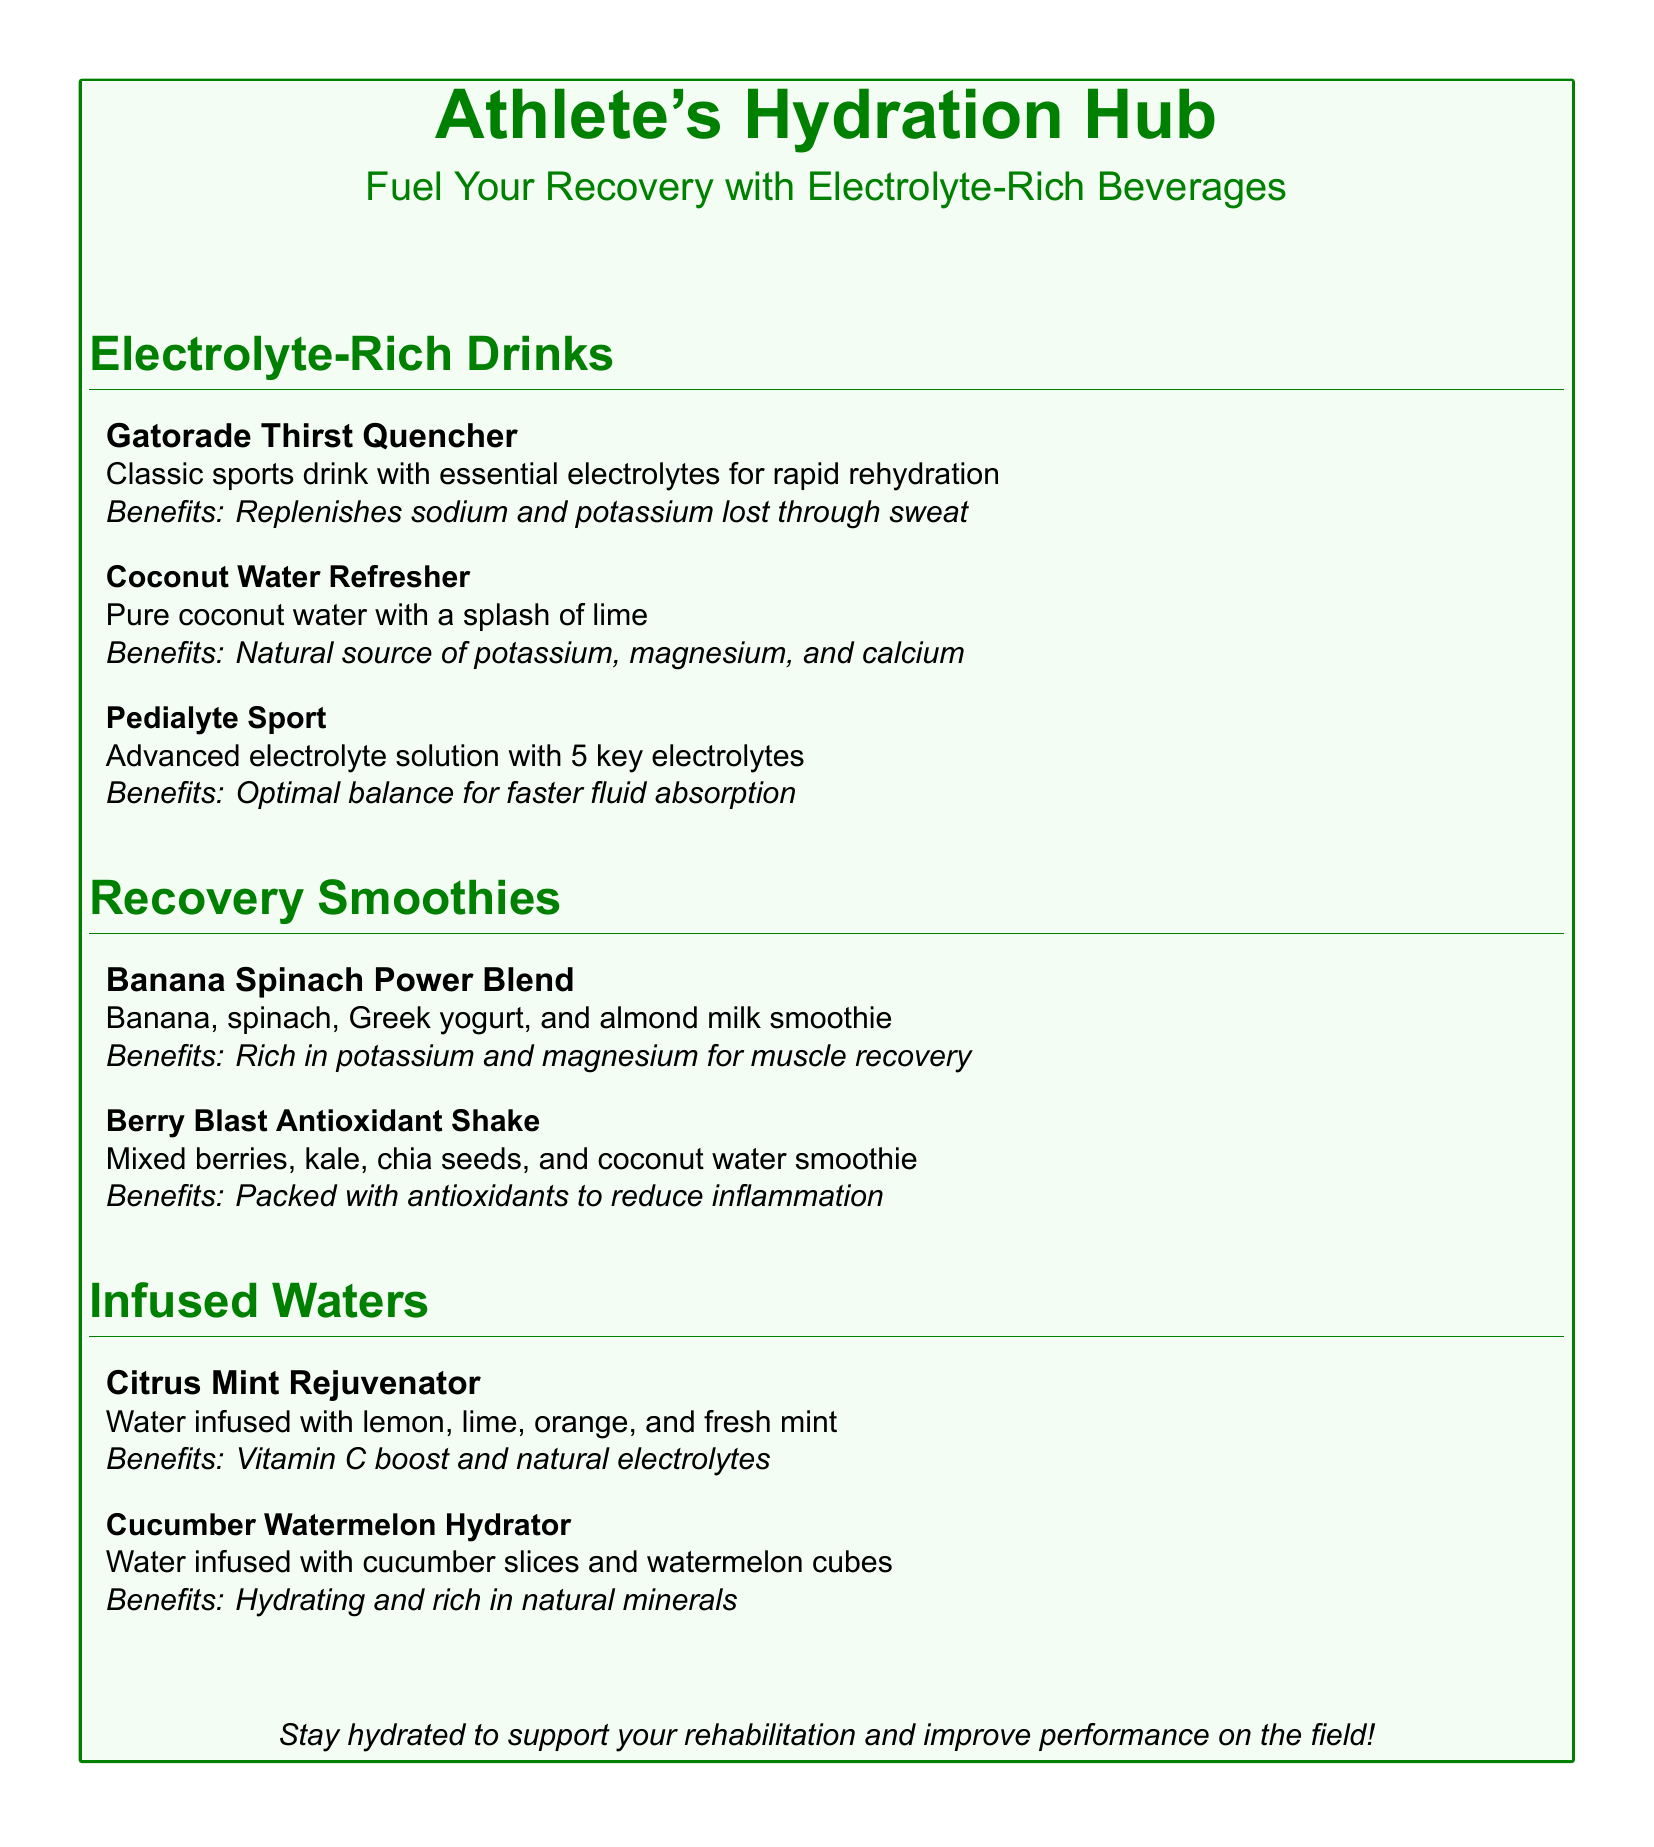What are the ingredients of the Banana Spinach Power Blend? The ingredients listed for the Banana Spinach Power Blend are banana, spinach, Greek yogurt, and almond milk.
Answer: Banana, spinach, Greek yogurt, almond milk How many key electrolytes does Pedialyte Sport contain? Pedialyte Sport is noted to have 5 key electrolytes for proper hydration.
Answer: 5 What benefit does Gatorade Thirst Quencher provide? The document specifies that Gatorade Thirst Quencher replenishes sodium and potassium lost through sweat.
Answer: Replenishes sodium and potassium Which drink offers a Vitamin C boost? The Citrus Mint Rejuvenator is infused with lemon, lime, orange, and fresh mint, providing a Vitamin C boost.
Answer: Citrus Mint Rejuvenator What is the main source of potassium in the Coconut Water Refresher? The Coconut Water Refresher is a pure coconut water drink, which is a natural source of potassium.
Answer: Coconut water What are the benefits of the Berry Blast Antioxidant Shake? The Berry Blast Antioxidant Shake is packed with antioxidants to reduce inflammation.
Answer: Packed with antioxidants How is Cucumber Watermelon Hydrator described? Cucumber Watermelon Hydrator is described as water infused with cucumber slices and watermelon cubes, being hydrating and rich in minerals.
Answer: Hydrating and rich in minerals How does the menu categorize its items? The items on the menu are categorized into sections: Electrolyte-Rich Drinks, Recovery Smoothies, and Infused Waters.
Answer: Sections What is the main message of the document? The main message of the document emphasizes the importance of staying hydrated to support rehabilitation and improve performance.
Answer: Stay hydrated 